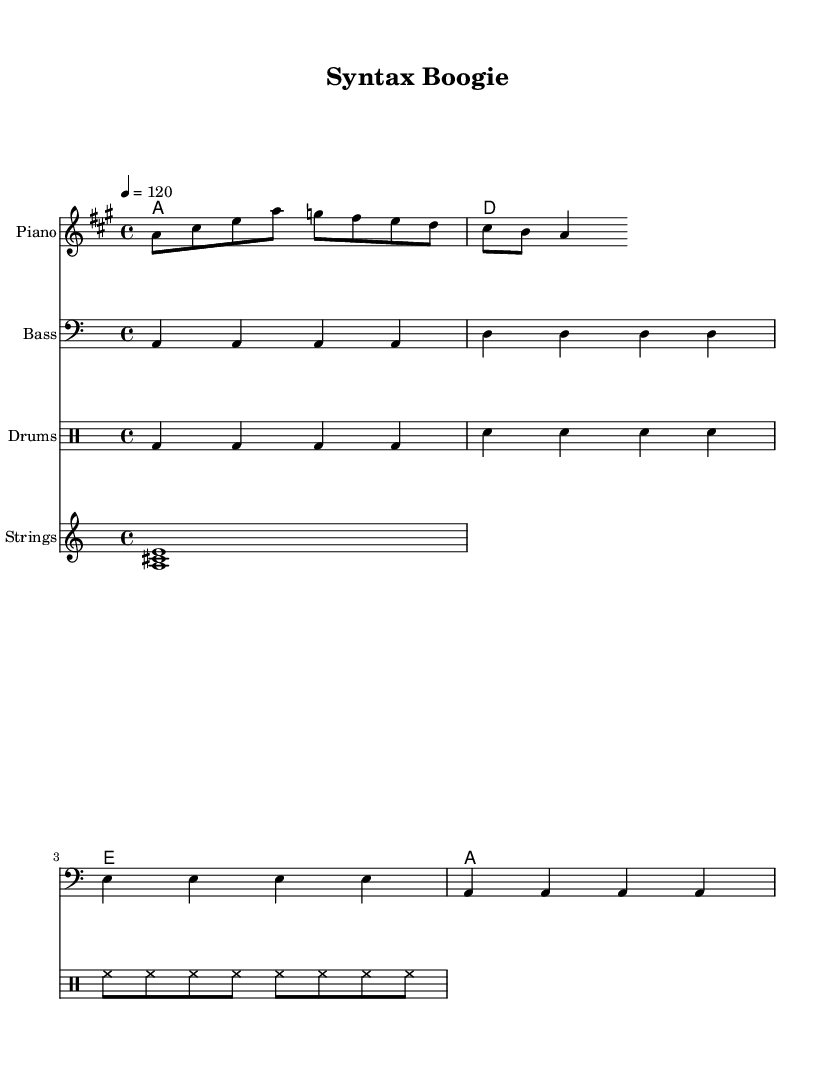What is the key signature of this music? The key signature is A major, which has three sharps (F#, C#, and G#). This can be determined by looking at the key signature indicated at the beginning of the score.
Answer: A major What is the time signature of this music? The time signature is 4/4, which is standard for disco music and can be seen at the beginning of the score. It indicates that there are four beats in each measure and the quarter note gets one beat.
Answer: 4/4 What is the tempo marking for this piece? The tempo marking is 4 = 120, meaning the quarter note should be played at a speed of 120 beats per minute. This can be read directly from the tempo indication in the score.
Answer: 120 How many measures long is the melody? The melody consists of four measures. By counting the bar lines in the melody section, we can see that there are four distinct measures.
Answer: 4 What instrument is primarily featured in the melody? The primary instrument featured in the melody is the piano, as denoted in the staff heading. The piano typically carries the main melodic line in disco compositions.
Answer: Piano What is the theme of the lyrics provided in this piece? The theme of the lyrics revolves around movement and rhythm, as indicated by the phrase "Let's parse this groove, it's time to move." This reflects typical disco themes of dance and enjoyment.
Answer: Groove 